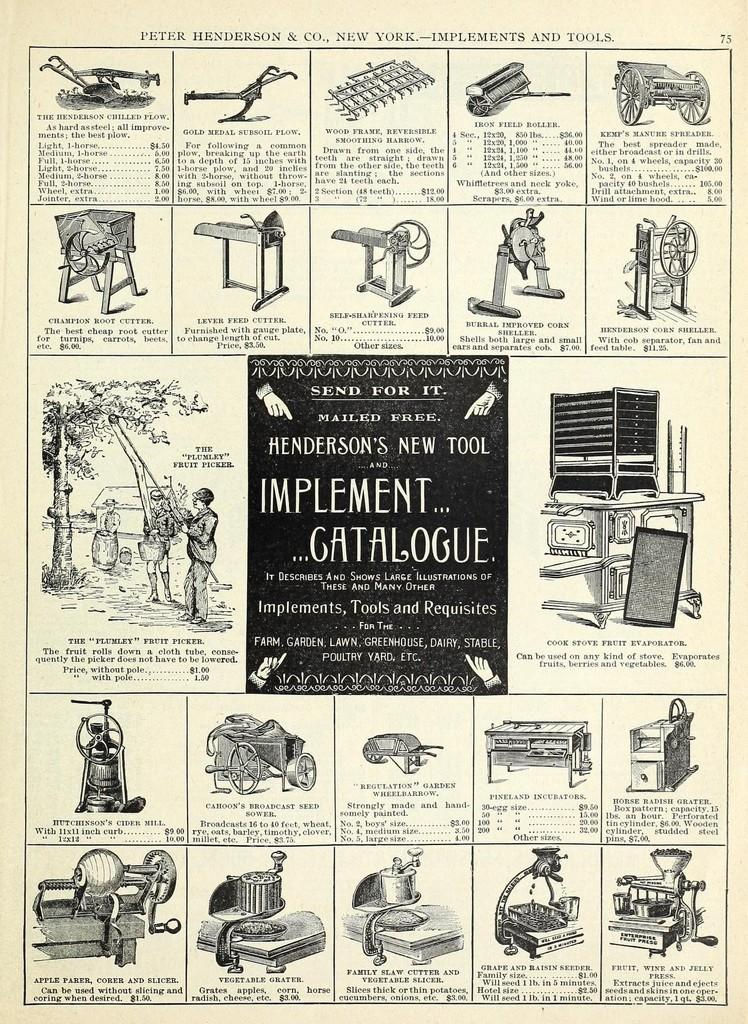What is the main subject of the paper in the image? The paper contains images of machines and other things. Can you describe the content of the paper in more detail? The paper contains images of machines and other things, as well as text. What type of skirt is visible in the image? There is no skirt present in the image; the image contains a paper with images of machines and other things, as well as text. 